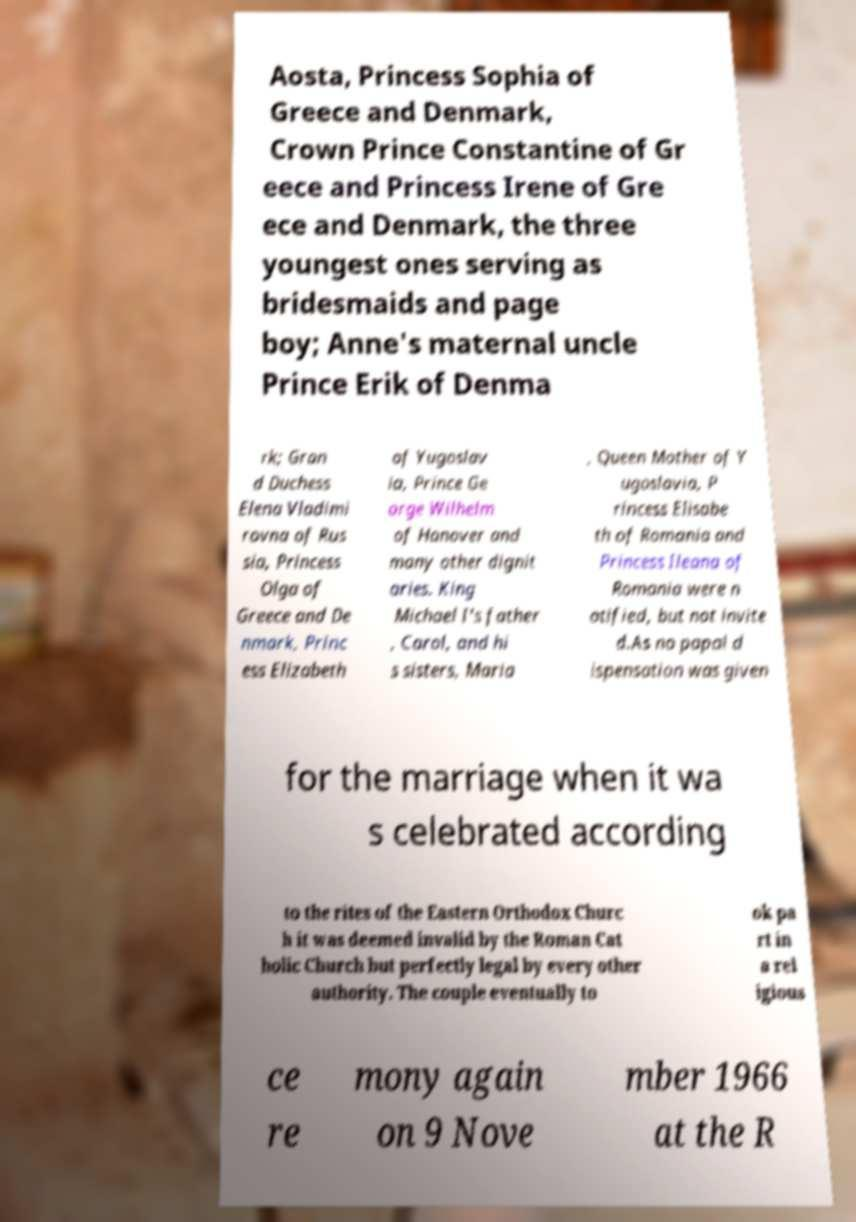Please identify and transcribe the text found in this image. Aosta, Princess Sophia of Greece and Denmark, Crown Prince Constantine of Gr eece and Princess Irene of Gre ece and Denmark, the three youngest ones serving as bridesmaids and page boy; Anne's maternal uncle Prince Erik of Denma rk; Gran d Duchess Elena Vladimi rovna of Rus sia, Princess Olga of Greece and De nmark, Princ ess Elizabeth of Yugoslav ia, Prince Ge orge Wilhelm of Hanover and many other dignit aries. King Michael I's father , Carol, and hi s sisters, Maria , Queen Mother of Y ugoslavia, P rincess Elisabe th of Romania and Princess Ileana of Romania were n otified, but not invite d.As no papal d ispensation was given for the marriage when it wa s celebrated according to the rites of the Eastern Orthodox Churc h it was deemed invalid by the Roman Cat holic Church but perfectly legal by every other authority. The couple eventually to ok pa rt in a rel igious ce re mony again on 9 Nove mber 1966 at the R 